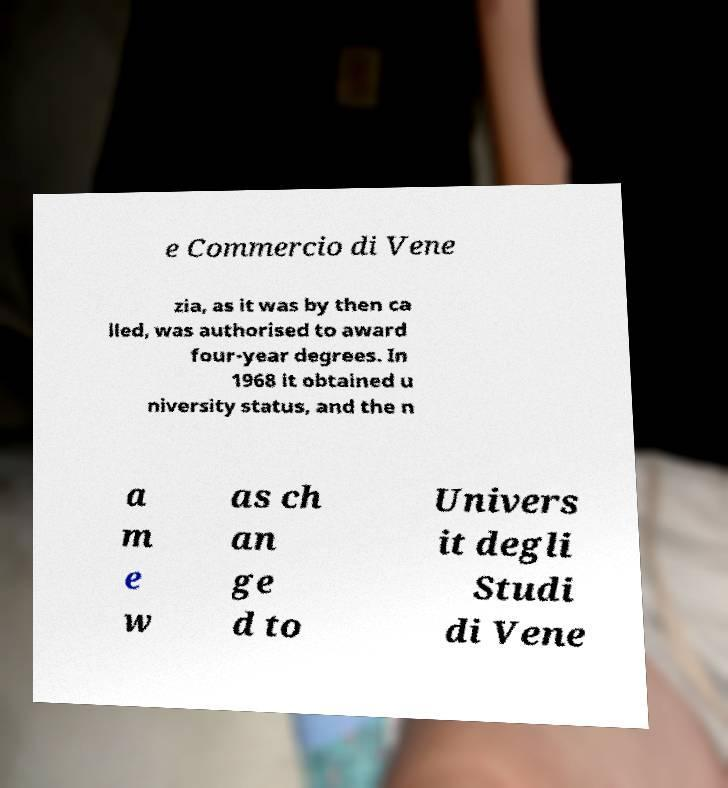Can you read and provide the text displayed in the image?This photo seems to have some interesting text. Can you extract and type it out for me? e Commercio di Vene zia, as it was by then ca lled, was authorised to award four-year degrees. In 1968 it obtained u niversity status, and the n a m e w as ch an ge d to Univers it degli Studi di Vene 